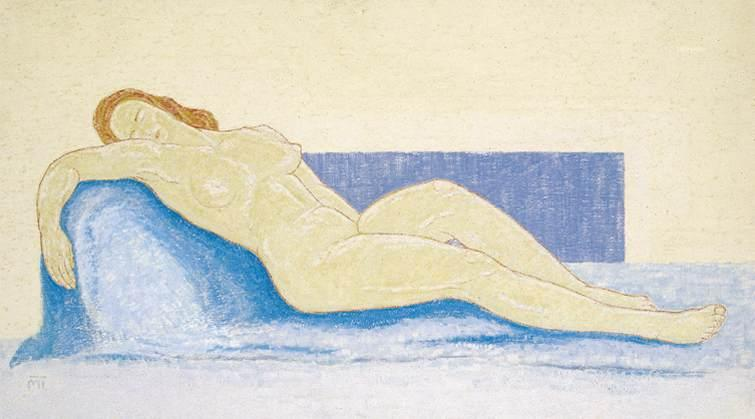Imagine the scene depicted in this drawing comes to life. What might the woman be thinking or feeling? If this scene were to come to life, the woman might be feeling a profound sense of peace and relaxation. Her pose suggests she is in a moment of repose, perhaps savoring a quiet afternoon. She might be daydreaming, her thoughts wandering to fond memories or future possibilities. The serene atmosphere created by the soft pastel colors could imply a feeling of contentment and comfort, as if she is lost in a moment of contemplation, free from worries and distractions. 